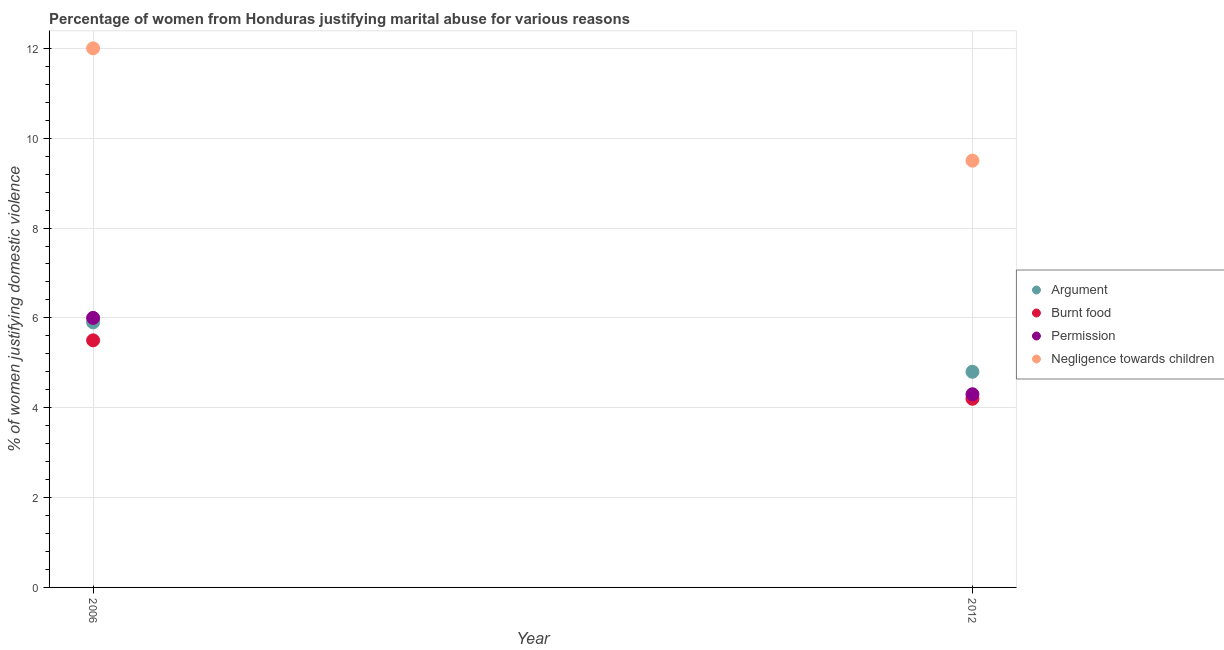How many different coloured dotlines are there?
Ensure brevity in your answer.  4. Is the number of dotlines equal to the number of legend labels?
Provide a short and direct response. Yes. What is the percentage of women justifying abuse for showing negligence towards children in 2012?
Your answer should be very brief. 9.5. Across all years, what is the maximum percentage of women justifying abuse for burning food?
Provide a short and direct response. 5.5. What is the difference between the percentage of women justifying abuse in the case of an argument in 2006 and that in 2012?
Provide a short and direct response. 1.1. What is the difference between the percentage of women justifying abuse for showing negligence towards children in 2006 and the percentage of women justifying abuse for going without permission in 2012?
Your answer should be very brief. 7.7. What is the average percentage of women justifying abuse in the case of an argument per year?
Provide a succinct answer. 5.35. In the year 2012, what is the difference between the percentage of women justifying abuse for showing negligence towards children and percentage of women justifying abuse for burning food?
Ensure brevity in your answer.  5.3. In how many years, is the percentage of women justifying abuse for showing negligence towards children greater than 1.6 %?
Ensure brevity in your answer.  2. What is the ratio of the percentage of women justifying abuse for burning food in 2006 to that in 2012?
Offer a terse response. 1.31. Is the percentage of women justifying abuse for going without permission in 2006 less than that in 2012?
Your answer should be very brief. No. In how many years, is the percentage of women justifying abuse in the case of an argument greater than the average percentage of women justifying abuse in the case of an argument taken over all years?
Make the answer very short. 1. Is it the case that in every year, the sum of the percentage of women justifying abuse in the case of an argument and percentage of women justifying abuse for burning food is greater than the percentage of women justifying abuse for going without permission?
Your answer should be very brief. Yes. Does the percentage of women justifying abuse for going without permission monotonically increase over the years?
Your answer should be very brief. No. Is the percentage of women justifying abuse for going without permission strictly less than the percentage of women justifying abuse for showing negligence towards children over the years?
Make the answer very short. Yes. How many years are there in the graph?
Give a very brief answer. 2. How many legend labels are there?
Ensure brevity in your answer.  4. What is the title of the graph?
Offer a terse response. Percentage of women from Honduras justifying marital abuse for various reasons. Does "Social Assistance" appear as one of the legend labels in the graph?
Give a very brief answer. No. What is the label or title of the Y-axis?
Your response must be concise. % of women justifying domestic violence. What is the % of women justifying domestic violence of Permission in 2006?
Your answer should be very brief. 6. What is the % of women justifying domestic violence of Negligence towards children in 2012?
Your answer should be compact. 9.5. Across all years, what is the maximum % of women justifying domestic violence of Argument?
Your answer should be very brief. 5.9. Across all years, what is the maximum % of women justifying domestic violence of Negligence towards children?
Offer a terse response. 12. Across all years, what is the minimum % of women justifying domestic violence in Burnt food?
Offer a very short reply. 4.2. Across all years, what is the minimum % of women justifying domestic violence in Negligence towards children?
Offer a very short reply. 9.5. What is the total % of women justifying domestic violence of Argument in the graph?
Keep it short and to the point. 10.7. What is the total % of women justifying domestic violence in Burnt food in the graph?
Your answer should be compact. 9.7. What is the total % of women justifying domestic violence of Permission in the graph?
Your response must be concise. 10.3. What is the total % of women justifying domestic violence of Negligence towards children in the graph?
Give a very brief answer. 21.5. What is the difference between the % of women justifying domestic violence of Permission in 2006 and that in 2012?
Keep it short and to the point. 1.7. What is the difference between the % of women justifying domestic violence in Negligence towards children in 2006 and that in 2012?
Your answer should be compact. 2.5. What is the average % of women justifying domestic violence in Argument per year?
Offer a terse response. 5.35. What is the average % of women justifying domestic violence of Burnt food per year?
Your response must be concise. 4.85. What is the average % of women justifying domestic violence of Permission per year?
Offer a very short reply. 5.15. What is the average % of women justifying domestic violence of Negligence towards children per year?
Make the answer very short. 10.75. In the year 2006, what is the difference between the % of women justifying domestic violence of Argument and % of women justifying domestic violence of Burnt food?
Your answer should be very brief. 0.4. In the year 2006, what is the difference between the % of women justifying domestic violence of Argument and % of women justifying domestic violence of Permission?
Your answer should be very brief. -0.1. In the year 2006, what is the difference between the % of women justifying domestic violence in Burnt food and % of women justifying domestic violence in Permission?
Provide a short and direct response. -0.5. In the year 2006, what is the difference between the % of women justifying domestic violence in Burnt food and % of women justifying domestic violence in Negligence towards children?
Ensure brevity in your answer.  -6.5. In the year 2012, what is the difference between the % of women justifying domestic violence in Argument and % of women justifying domestic violence in Burnt food?
Ensure brevity in your answer.  0.6. In the year 2012, what is the difference between the % of women justifying domestic violence of Argument and % of women justifying domestic violence of Negligence towards children?
Your answer should be compact. -4.7. In the year 2012, what is the difference between the % of women justifying domestic violence in Burnt food and % of women justifying domestic violence in Permission?
Give a very brief answer. -0.1. In the year 2012, what is the difference between the % of women justifying domestic violence of Burnt food and % of women justifying domestic violence of Negligence towards children?
Make the answer very short. -5.3. What is the ratio of the % of women justifying domestic violence in Argument in 2006 to that in 2012?
Provide a succinct answer. 1.23. What is the ratio of the % of women justifying domestic violence of Burnt food in 2006 to that in 2012?
Make the answer very short. 1.31. What is the ratio of the % of women justifying domestic violence of Permission in 2006 to that in 2012?
Offer a very short reply. 1.4. What is the ratio of the % of women justifying domestic violence in Negligence towards children in 2006 to that in 2012?
Your answer should be compact. 1.26. What is the difference between the highest and the second highest % of women justifying domestic violence in Argument?
Your answer should be compact. 1.1. What is the difference between the highest and the second highest % of women justifying domestic violence in Burnt food?
Ensure brevity in your answer.  1.3. What is the difference between the highest and the second highest % of women justifying domestic violence in Negligence towards children?
Keep it short and to the point. 2.5. What is the difference between the highest and the lowest % of women justifying domestic violence in Argument?
Give a very brief answer. 1.1. What is the difference between the highest and the lowest % of women justifying domestic violence in Burnt food?
Keep it short and to the point. 1.3. What is the difference between the highest and the lowest % of women justifying domestic violence in Permission?
Your response must be concise. 1.7. 